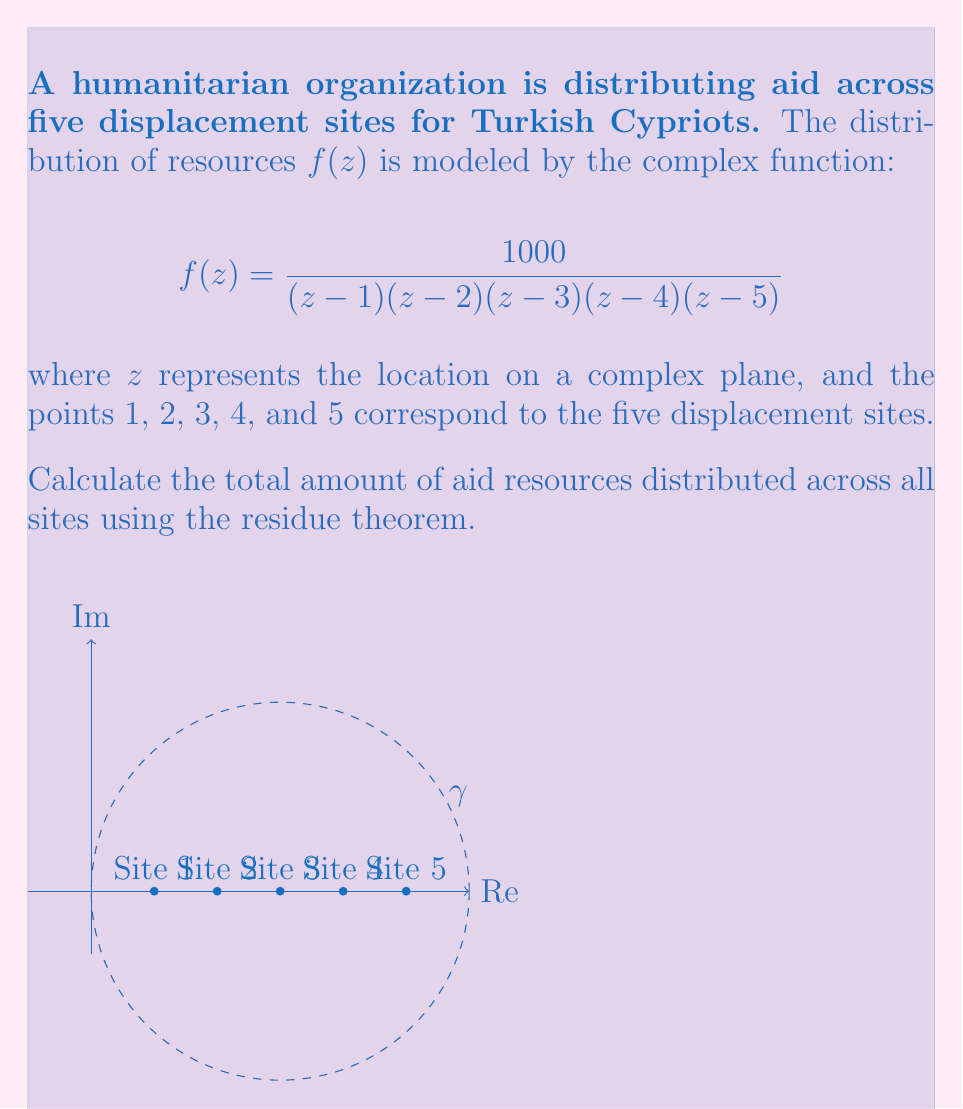Solve this math problem. To solve this problem, we'll use the residue theorem:

$$\oint_\gamma f(z) dz = 2\pi i \sum_{k=1}^n \text{Res}(f, z_k)$$

where $\gamma$ is a simple closed curve enclosing all the poles of $f(z)$.

1) First, we need to find the residues at each pole (site location):

For $z_k = 1, 2, 3, 4, 5$, we can use the formula for simple poles:

$$\text{Res}(f, z_k) = \lim_{z \to z_k} (z-z_k)f(z)$$

2) Let's calculate the residue for $z_1 = 1$:

$$\text{Res}(f, 1) = \lim_{z \to 1} \frac{1000}{(z-2)(z-3)(z-4)(z-5)} = \frac{1000}{(-1)(-2)(-3)(-4)} = \frac{1000}{24} = \frac{125}{3}$$

3) Similarly, for the other poles:

$$\text{Res}(f, 2) = \frac{1000}{(1)(-1)(-2)(-3)} = -\frac{1000}{6} = -\frac{500}{3}$$
$$\text{Res}(f, 3) = \frac{1000}{(2)(1)(-1)(-2)} = \frac{1000}{4} = 250$$
$$\text{Res}(f, 4) = \frac{1000}{(3)(2)(1)(-1)} = -\frac{1000}{6} = -\frac{500}{3}$$
$$\text{Res}(f, 5) = \frac{1000}{(4)(3)(2)(1)} = \frac{1000}{24} = \frac{125}{3}$$

4) Now, we sum all the residues:

$$\sum_{k=1}^5 \text{Res}(f, z_k) = \frac{125}{3} - \frac{500}{3} + 250 - \frac{500}{3} + \frac{125}{3} = 0$$

5) Applying the residue theorem:

$$\oint_\gamma f(z) dz = 2\pi i (0) = 0$$

Therefore, the total amount of aid resources distributed across all sites is 0.
Answer: 0 